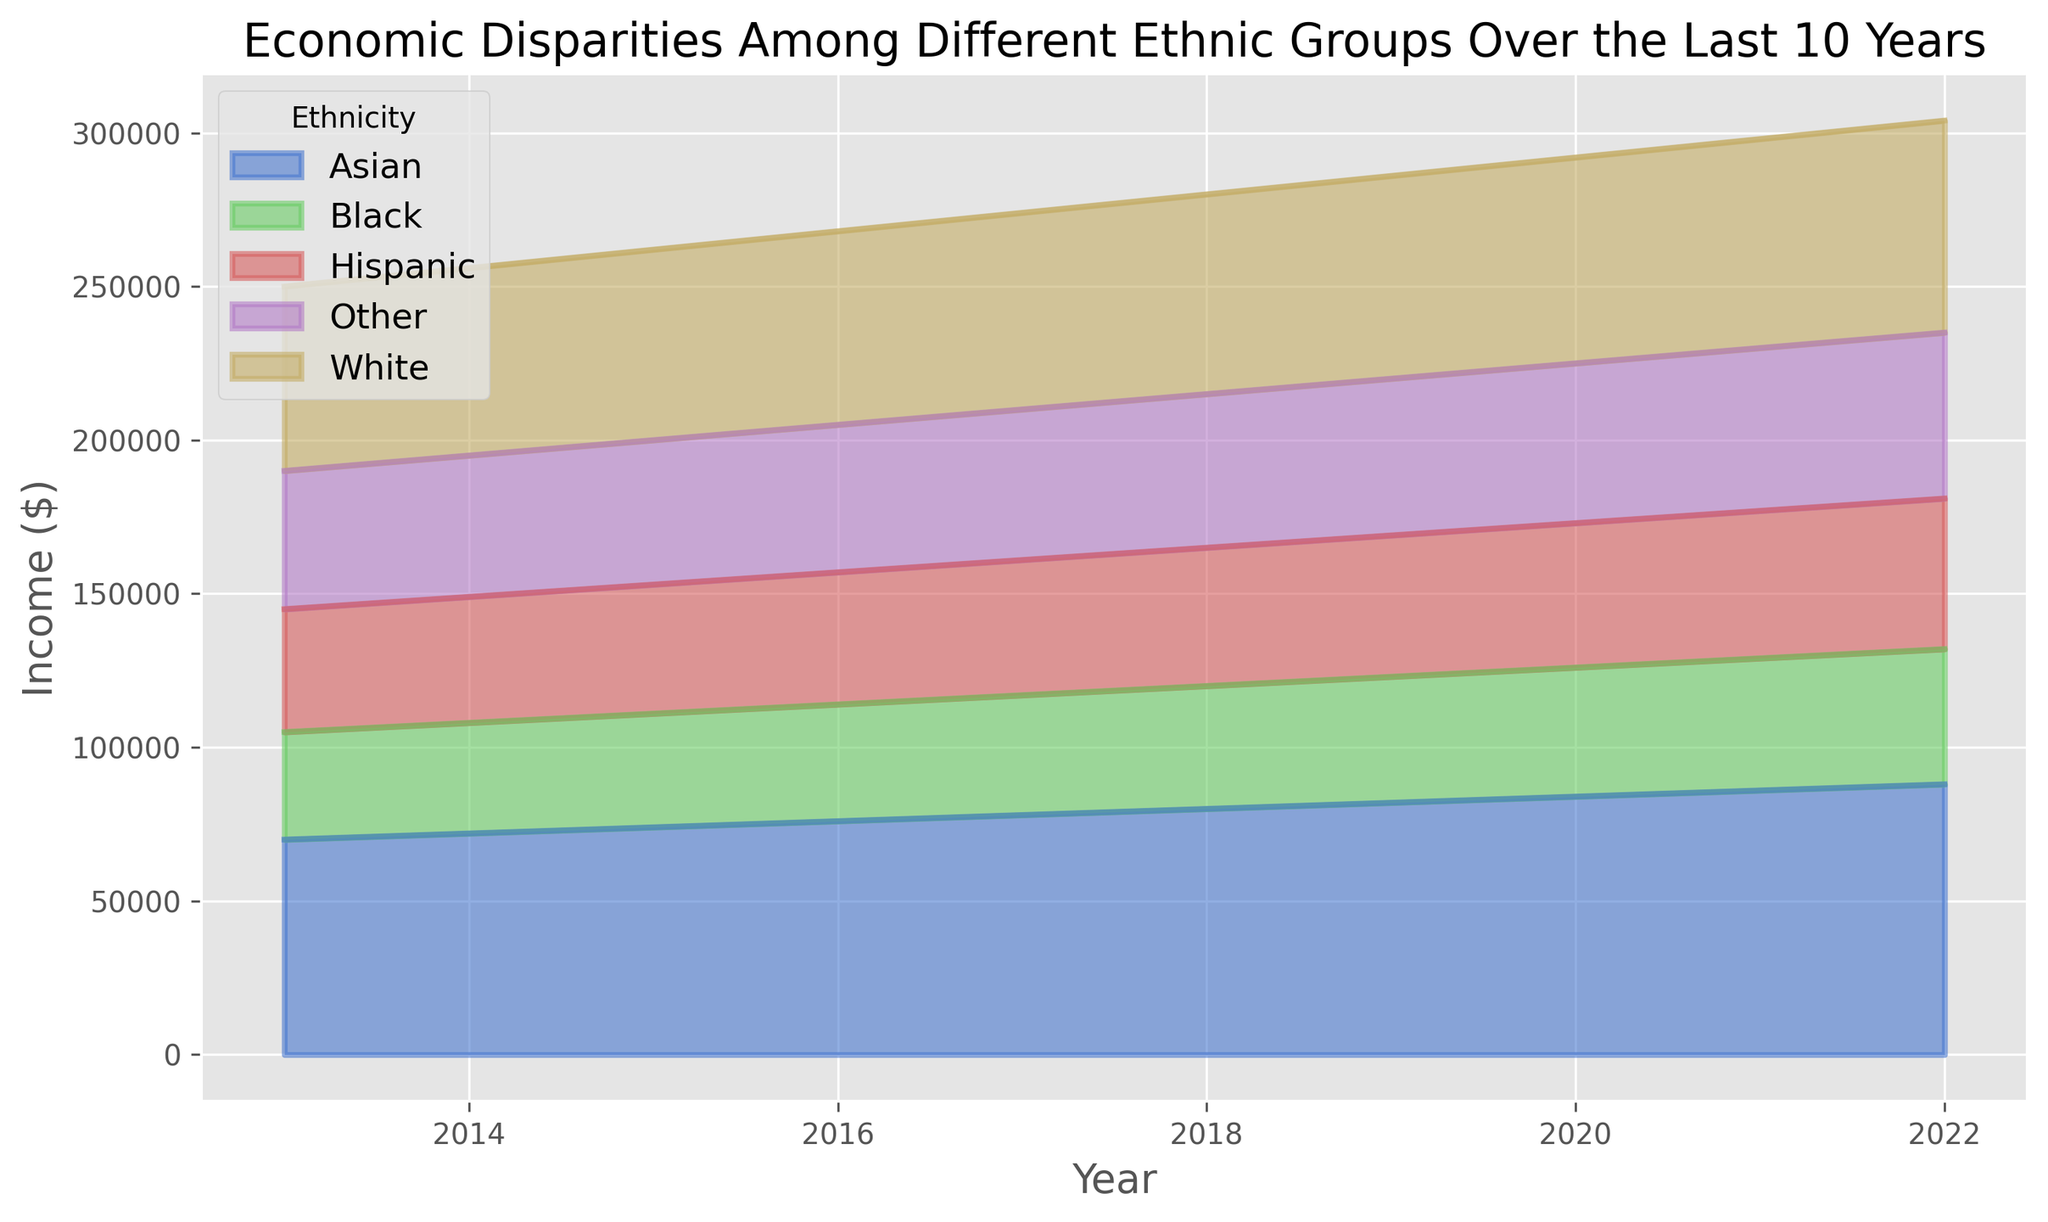Which ethnic group had the highest income in 2022? By looking at the area chart, we can see that the highest area in 2022 corresponds to the income of the Asian ethnic group.
Answer: Asian How did the income for the Black ethnic group change from 2013 to 2022? To determine this, refer to the area chart and compare the height of the area representing the Black ethnic group in 2013 and 2022. In 2013, the income was $35,000, and in 2022, it increased to $44,000.
Answer: Increased by $9,000 What was the average income for the Hispanic ethnic group between 2013 and 2022? To calculate the average income, sum up the income figures for Hispanic ethnicity from 2013 to 2022 and divide by the total number of years. (40000 + 41000 + 42000 + 43000 + 44000 + 45000 + 46000 + 47000 + 48000 + 49000) / 10 = 44500.
Answer: $44,500 Which ethnic group had the smallest income increase from 2013 to 2022? To find this, calculate the difference in income from 2013 to 2022 for each ethnic group. The smallest increase corresponds to the ethnic group with the least difference. White: $60000 to $69000 = $9,000; Black: $35000 to $44000 = $9,000; Hispanic: $40000 to $49000 = $9,000; Asian: $70000 to $88000 = $18,000; Other: $45000 to $54000 = $9,000.
Answer: All groups except Asian By how much did the income disparity between the highest and lowest-earning ethnic group change from 2013 to 2022? In 2013, the highest income was Asian at $70,000 and the lowest was Black at $35,000. The disparity was $35,000. In 2022, the highest was Asian at $88,000 and the lowest was Black at $44,000. The disparity became $44,000. The change in disparity is $44,000 - $35,000 = $9,000.
Answer: Increased by $9,000 Which year did the White ethnic group surpass an average income of $65,000? Locate the year when the height of the area representing the White ethnic group first crosses the $65,000 mark. The chart shows this happening in 2018.
Answer: 2018 What is the rate of income growth for the Asian ethnic group from 2015 to 2020? To find the growth rate, calculate the difference between the income in 2020 and 2015, then divide by the income in 2015, and multiply by 100. (84000 - 74000) / 74000 * 100 ≈ 13.51%.
Answer: Approximately 13.51% Comparing 2016 and 2018, which ethnic group experienced the highest income growth? Calculate the growth for each ethnic group between these years and compare. White: $65000 - $63000 = $2000; Black: $40000 - $38000 = $2000; Hispanic: $45000 - $43000 = $2000; Asian: $80000 - $76000 = $4000; Other: $50000 - $48000 = $2000. The Asian ethnic group experienced the highest growth.
Answer: Asian What is the difference in income for the "Other" ethnic group between 2017 and 2019? Refer to the area chart, and find the income for the "Other" ethnic group in 2017 ($49,000) and 2019 ($51,000). The difference is $51,000 - $49,000 = $2,000.
Answer: $2,000 